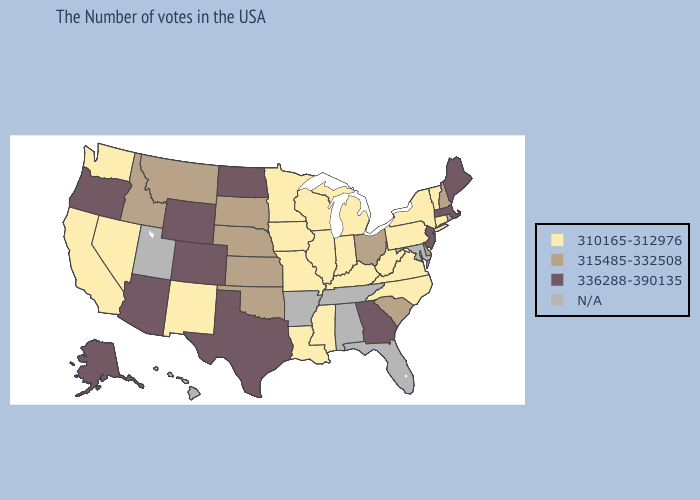Does Rhode Island have the lowest value in the USA?
Answer briefly. No. Name the states that have a value in the range N/A?
Keep it brief. Maryland, Florida, Alabama, Tennessee, Arkansas, Utah, Hawaii. Among the states that border Louisiana , does Texas have the lowest value?
Be succinct. No. What is the lowest value in the USA?
Concise answer only. 310165-312976. What is the value of Oklahoma?
Write a very short answer. 315485-332508. How many symbols are there in the legend?
Quick response, please. 4. Among the states that border Florida , which have the lowest value?
Answer briefly. Georgia. Does Washington have the lowest value in the USA?
Short answer required. Yes. Name the states that have a value in the range 336288-390135?
Answer briefly. Maine, Massachusetts, New Jersey, Georgia, Texas, North Dakota, Wyoming, Colorado, Arizona, Oregon, Alaska. What is the value of Nevada?
Write a very short answer. 310165-312976. How many symbols are there in the legend?
Answer briefly. 4. What is the highest value in the USA?
Be succinct. 336288-390135. Does Kentucky have the highest value in the South?
Quick response, please. No. 